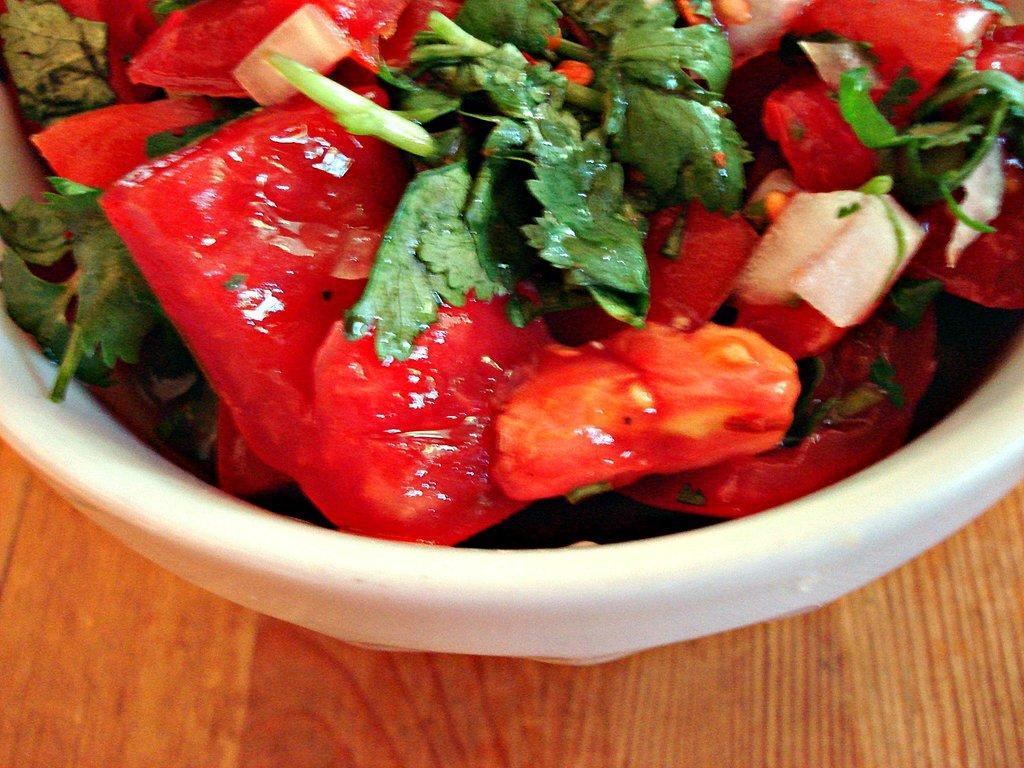What type of food items are present in the image? There are vegetables and tomato pieces in the image. Can you describe the vegetables in the image? The vegetables in the image are leafy vegetables. How are the vegetables and tomato pieces arranged in the image? The vegetables and tomato pieces are in a white color bowl. Where is the bowl placed in the image? The bowl is placed on a brown color table. What type of bun is being used to hold the vegetables in the image? There is no bun present in the image; the vegetables and tomato pieces are in a white color bowl. 